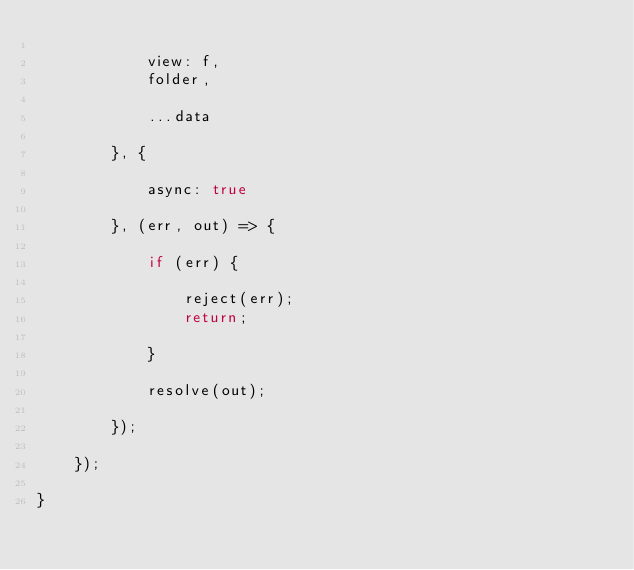Convert code to text. <code><loc_0><loc_0><loc_500><loc_500><_JavaScript_>
			view: f,
			folder,

			...data

		}, {
			
			async: true
		
		}, (err, out) => {

			if (err) {

				reject(err);
				return;

			}

			resolve(out);

		});

	});

}
</code> 